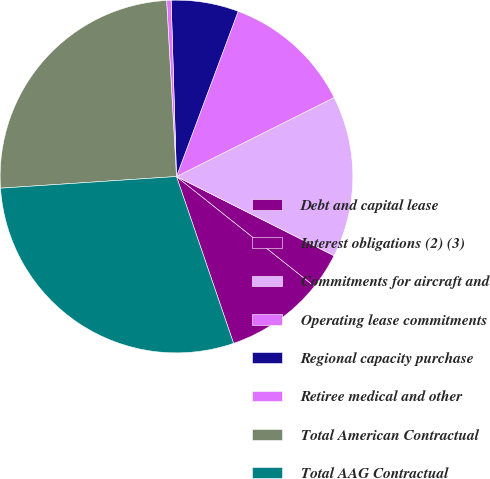Convert chart. <chart><loc_0><loc_0><loc_500><loc_500><pie_chart><fcel>Debt and capital lease<fcel>Interest obligations (2) (3)<fcel>Commitments for aircraft and<fcel>Operating lease commitments<fcel>Regional capacity purchase<fcel>Retiree medical and other<fcel>Total American Contractual<fcel>Total AAG Contractual<nl><fcel>9.05%<fcel>3.29%<fcel>14.8%<fcel>11.92%<fcel>6.17%<fcel>0.41%<fcel>25.16%<fcel>29.19%<nl></chart> 